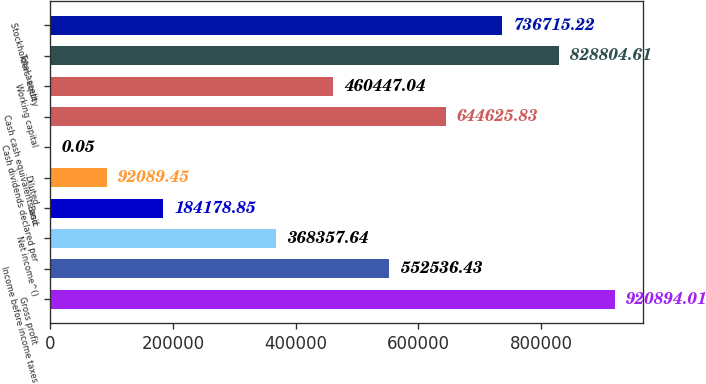Convert chart to OTSL. <chart><loc_0><loc_0><loc_500><loc_500><bar_chart><fcel>Gross profit<fcel>Income before income taxes<fcel>Net income^()<fcel>Basic<fcel>Diluted<fcel>Cash dividends declared per<fcel>Cash cash equivalents and<fcel>Working capital<fcel>Total assets<fcel>Stockholders' equity<nl><fcel>920894<fcel>552536<fcel>368358<fcel>184179<fcel>92089.4<fcel>0.05<fcel>644626<fcel>460447<fcel>828805<fcel>736715<nl></chart> 